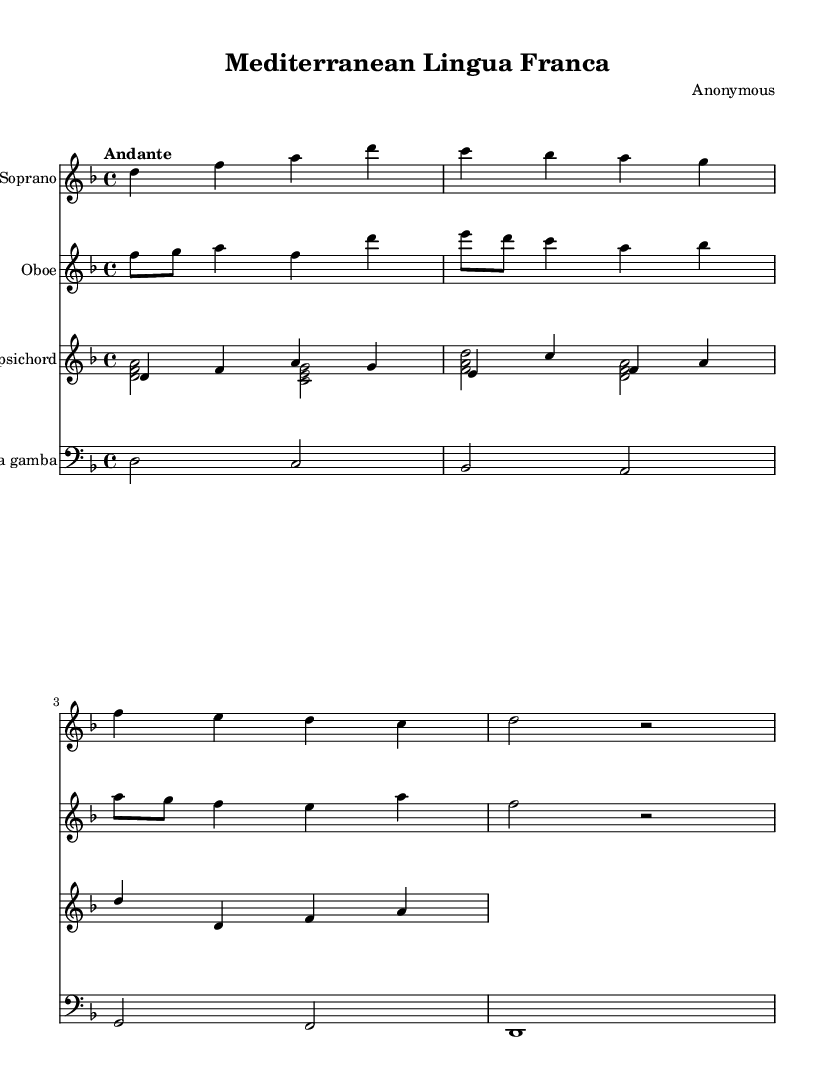what is the key signature of this music? The key signature is indicated at the beginning of the staff. In this case, there are one flat (B), which indicates D minor or F major. The context of the piece suggests D minor as the key.
Answer: D minor what is the time signature of this music? The time signature is found at the beginning of the score, represented by the fraction. Here, it shows 4/4, meaning there are four beats in each measure, and the quarter note gets one beat.
Answer: 4/4 what is the tempo marking of this music? The tempo marking appears at the beginning of the score and indicates the speed at which the piece is to be played. "Andante" suggests a moderate speed, typically around 76-108 beats per minute.
Answer: Andante how many instruments are specified in this score? The score includes multiple staves indicating different instruments. By counting each staff, we see there are four separate instruments: Soprano, Oboe, Harpsichord, and Viola da gamba, totaling four instruments.
Answer: Four what is the function of the harpsichord in this piece? In Baroque music, the harpsichord typically serves a continuo role, providing harmonic support and filling in chords. Looking at the part, we see it plays both melody and accompaniment, indicative of its role in ensemble settings.
Answer: Continuo does the soprano line include a repeated note? By analyzing the soprano part, we observe the notes in sequence. The note "d" is repeated in the phrase "Mer -- kan -- ti", confirming that there is a repeated note.
Answer: Yes which musical form is primarily present in this Baroque piece? The structure of the piece shows a short, lyrical melody characteristic of Baroque solo vocal music combined with instrumental parts. Each line follows a structured phrasing style typical of aria or operatic forms.
Answer: Aria 